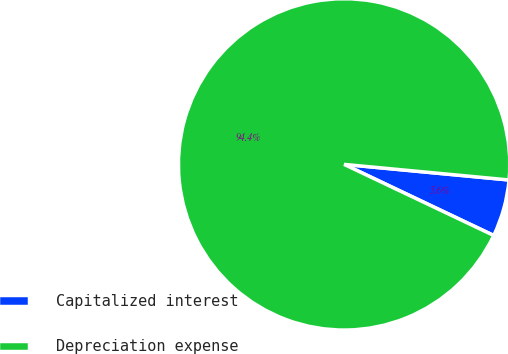<chart> <loc_0><loc_0><loc_500><loc_500><pie_chart><fcel>Capitalized interest<fcel>Depreciation expense<nl><fcel>5.56%<fcel>94.44%<nl></chart> 